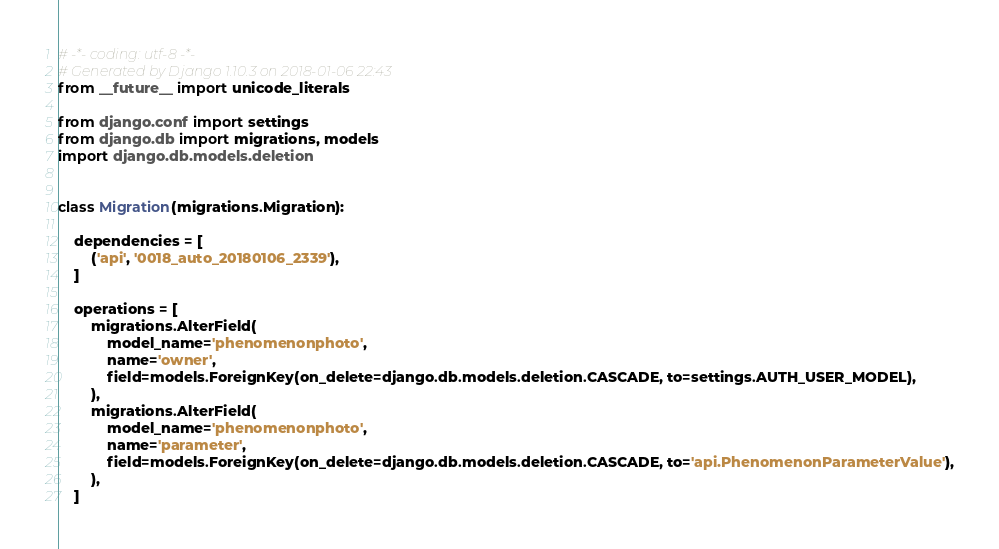<code> <loc_0><loc_0><loc_500><loc_500><_Python_># -*- coding: utf-8 -*-
# Generated by Django 1.10.3 on 2018-01-06 22:43
from __future__ import unicode_literals

from django.conf import settings
from django.db import migrations, models
import django.db.models.deletion


class Migration(migrations.Migration):

    dependencies = [
        ('api', '0018_auto_20180106_2339'),
    ]

    operations = [
        migrations.AlterField(
            model_name='phenomenonphoto',
            name='owner',
            field=models.ForeignKey(on_delete=django.db.models.deletion.CASCADE, to=settings.AUTH_USER_MODEL),
        ),
        migrations.AlterField(
            model_name='phenomenonphoto',
            name='parameter',
            field=models.ForeignKey(on_delete=django.db.models.deletion.CASCADE, to='api.PhenomenonParameterValue'),
        ),
    ]
</code> 